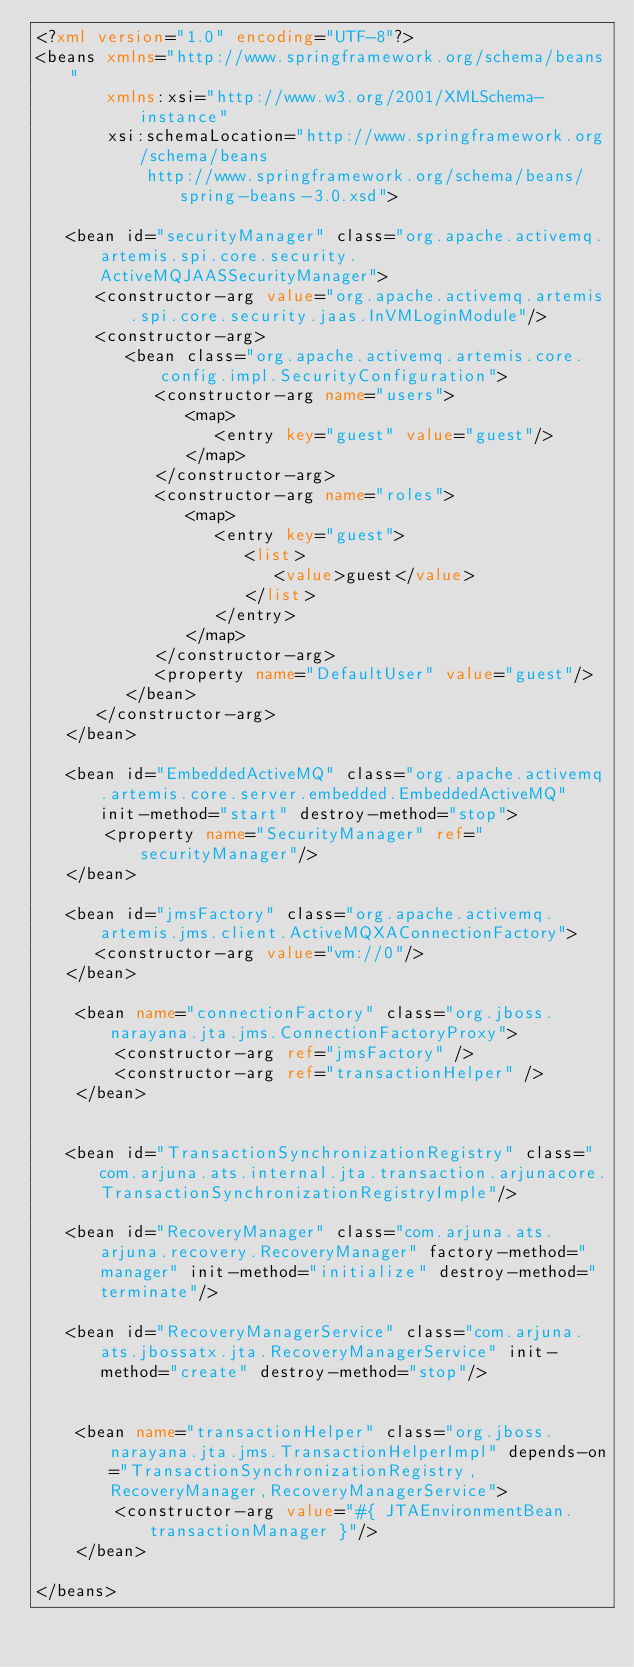<code> <loc_0><loc_0><loc_500><loc_500><_XML_><?xml version="1.0" encoding="UTF-8"?>
<beans xmlns="http://www.springframework.org/schema/beans"
       xmlns:xsi="http://www.w3.org/2001/XMLSchema-instance"
       xsi:schemaLocation="http://www.springframework.org/schema/beans
           http://www.springframework.org/schema/beans/spring-beans-3.0.xsd">

   <bean id="securityManager" class="org.apache.activemq.artemis.spi.core.security.ActiveMQJAASSecurityManager">
      <constructor-arg value="org.apache.activemq.artemis.spi.core.security.jaas.InVMLoginModule"/>
      <constructor-arg>
         <bean class="org.apache.activemq.artemis.core.config.impl.SecurityConfiguration">
            <constructor-arg name="users">
               <map>
                  <entry key="guest" value="guest"/>
               </map>
            </constructor-arg>
            <constructor-arg name="roles">
               <map>
                  <entry key="guest">
                     <list>
                        <value>guest</value>
                     </list>
                  </entry>
               </map>
            </constructor-arg>
            <property name="DefaultUser" value="guest"/>
         </bean>
      </constructor-arg>
   </bean>

   <bean id="EmbeddedActiveMQ" class="org.apache.activemq.artemis.core.server.embedded.EmbeddedActiveMQ" init-method="start" destroy-method="stop">
       <property name="SecurityManager" ref="securityManager"/>
   </bean>

   <bean id="jmsFactory" class="org.apache.activemq.artemis.jms.client.ActiveMQXAConnectionFactory">
      <constructor-arg value="vm://0"/>
   </bean>

	<bean name="connectionFactory" class="org.jboss.narayana.jta.jms.ConnectionFactoryProxy">
		<constructor-arg ref="jmsFactory" />
		<constructor-arg ref="transactionHelper" />
	</bean>
	
	
   <bean id="TransactionSynchronizationRegistry" class="com.arjuna.ats.internal.jta.transaction.arjunacore.TransactionSynchronizationRegistryImple"/>
	
   <bean id="RecoveryManager" class="com.arjuna.ats.arjuna.recovery.RecoveryManager" factory-method="manager" init-method="initialize" destroy-method="terminate"/>

   <bean id="RecoveryManagerService" class="com.arjuna.ats.jbossatx.jta.RecoveryManagerService" init-method="create" destroy-method="stop"/>
   

	<bean name="transactionHelper" class="org.jboss.narayana.jta.jms.TransactionHelperImpl" depends-on="TransactionSynchronizationRegistry,RecoveryManager,RecoveryManagerService">
		<constructor-arg value="#{ JTAEnvironmentBean.transactionManager }"/>
	</bean> 	
   
</beans>
</code> 